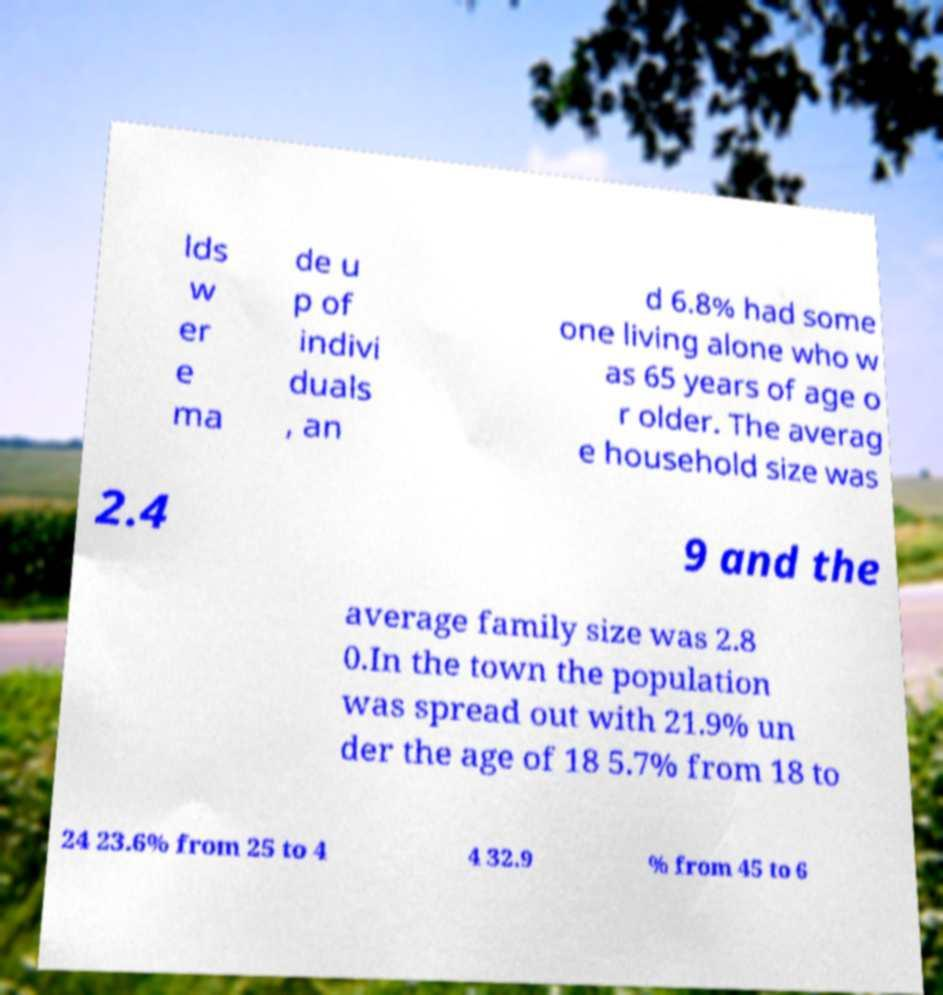Please read and relay the text visible in this image. What does it say? lds w er e ma de u p of indivi duals , an d 6.8% had some one living alone who w as 65 years of age o r older. The averag e household size was 2.4 9 and the average family size was 2.8 0.In the town the population was spread out with 21.9% un der the age of 18 5.7% from 18 to 24 23.6% from 25 to 4 4 32.9 % from 45 to 6 